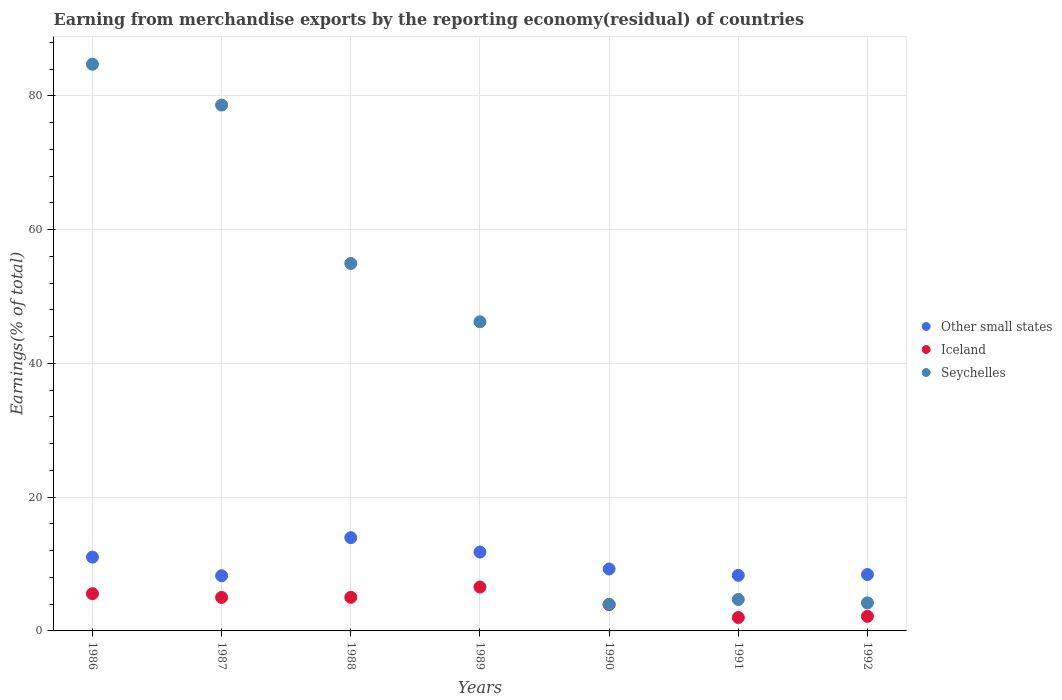How many different coloured dotlines are there?
Keep it short and to the point. 3. What is the percentage of amount earned from merchandise exports in Other small states in 1986?
Your response must be concise. 11.04. Across all years, what is the maximum percentage of amount earned from merchandise exports in Seychelles?
Ensure brevity in your answer.  84.75. Across all years, what is the minimum percentage of amount earned from merchandise exports in Iceland?
Offer a terse response. 2. In which year was the percentage of amount earned from merchandise exports in Other small states maximum?
Provide a short and direct response. 1988. In which year was the percentage of amount earned from merchandise exports in Seychelles minimum?
Make the answer very short. 1990. What is the total percentage of amount earned from merchandise exports in Seychelles in the graph?
Provide a succinct answer. 277.46. What is the difference between the percentage of amount earned from merchandise exports in Iceland in 1986 and that in 1988?
Keep it short and to the point. 0.54. What is the difference between the percentage of amount earned from merchandise exports in Other small states in 1991 and the percentage of amount earned from merchandise exports in Seychelles in 1990?
Ensure brevity in your answer.  4.33. What is the average percentage of amount earned from merchandise exports in Other small states per year?
Ensure brevity in your answer.  10.15. In the year 1987, what is the difference between the percentage of amount earned from merchandise exports in Other small states and percentage of amount earned from merchandise exports in Iceland?
Your response must be concise. 3.24. What is the ratio of the percentage of amount earned from merchandise exports in Seychelles in 1986 to that in 1992?
Provide a succinct answer. 20.19. Is the percentage of amount earned from merchandise exports in Other small states in 1988 less than that in 1992?
Provide a short and direct response. No. Is the difference between the percentage of amount earned from merchandise exports in Other small states in 1987 and 1992 greater than the difference between the percentage of amount earned from merchandise exports in Iceland in 1987 and 1992?
Keep it short and to the point. No. What is the difference between the highest and the second highest percentage of amount earned from merchandise exports in Iceland?
Provide a succinct answer. 1. What is the difference between the highest and the lowest percentage of amount earned from merchandise exports in Other small states?
Ensure brevity in your answer.  5.69. Is it the case that in every year, the sum of the percentage of amount earned from merchandise exports in Iceland and percentage of amount earned from merchandise exports in Seychelles  is greater than the percentage of amount earned from merchandise exports in Other small states?
Provide a succinct answer. No. Is the percentage of amount earned from merchandise exports in Iceland strictly less than the percentage of amount earned from merchandise exports in Seychelles over the years?
Offer a terse response. Yes. How many years are there in the graph?
Give a very brief answer. 7. Does the graph contain any zero values?
Keep it short and to the point. No. How many legend labels are there?
Ensure brevity in your answer.  3. How are the legend labels stacked?
Your answer should be compact. Vertical. What is the title of the graph?
Keep it short and to the point. Earning from merchandise exports by the reporting economy(residual) of countries. What is the label or title of the X-axis?
Provide a short and direct response. Years. What is the label or title of the Y-axis?
Your answer should be very brief. Earnings(% of total). What is the Earnings(% of total) in Other small states in 1986?
Ensure brevity in your answer.  11.04. What is the Earnings(% of total) of Iceland in 1986?
Keep it short and to the point. 5.56. What is the Earnings(% of total) in Seychelles in 1986?
Make the answer very short. 84.75. What is the Earnings(% of total) of Other small states in 1987?
Keep it short and to the point. 8.25. What is the Earnings(% of total) of Iceland in 1987?
Make the answer very short. 5.01. What is the Earnings(% of total) of Seychelles in 1987?
Offer a terse response. 78.64. What is the Earnings(% of total) of Other small states in 1988?
Give a very brief answer. 13.95. What is the Earnings(% of total) of Iceland in 1988?
Ensure brevity in your answer.  5.02. What is the Earnings(% of total) in Seychelles in 1988?
Keep it short and to the point. 54.95. What is the Earnings(% of total) in Other small states in 1989?
Your response must be concise. 11.79. What is the Earnings(% of total) of Iceland in 1989?
Provide a succinct answer. 6.56. What is the Earnings(% of total) in Seychelles in 1989?
Your answer should be very brief. 46.24. What is the Earnings(% of total) of Other small states in 1990?
Make the answer very short. 9.26. What is the Earnings(% of total) in Iceland in 1990?
Offer a very short reply. 3.94. What is the Earnings(% of total) of Seychelles in 1990?
Ensure brevity in your answer.  3.98. What is the Earnings(% of total) in Other small states in 1991?
Offer a very short reply. 8.31. What is the Earnings(% of total) of Iceland in 1991?
Offer a terse response. 2. What is the Earnings(% of total) of Seychelles in 1991?
Offer a very short reply. 4.7. What is the Earnings(% of total) of Other small states in 1992?
Your answer should be compact. 8.44. What is the Earnings(% of total) of Iceland in 1992?
Ensure brevity in your answer.  2.18. What is the Earnings(% of total) in Seychelles in 1992?
Keep it short and to the point. 4.2. Across all years, what is the maximum Earnings(% of total) in Other small states?
Your response must be concise. 13.95. Across all years, what is the maximum Earnings(% of total) of Iceland?
Make the answer very short. 6.56. Across all years, what is the maximum Earnings(% of total) in Seychelles?
Offer a terse response. 84.75. Across all years, what is the minimum Earnings(% of total) in Other small states?
Offer a terse response. 8.25. Across all years, what is the minimum Earnings(% of total) in Iceland?
Give a very brief answer. 2. Across all years, what is the minimum Earnings(% of total) of Seychelles?
Your answer should be very brief. 3.98. What is the total Earnings(% of total) of Other small states in the graph?
Offer a very short reply. 71.03. What is the total Earnings(% of total) in Iceland in the graph?
Your answer should be compact. 30.28. What is the total Earnings(% of total) in Seychelles in the graph?
Offer a terse response. 277.46. What is the difference between the Earnings(% of total) of Other small states in 1986 and that in 1987?
Give a very brief answer. 2.79. What is the difference between the Earnings(% of total) in Iceland in 1986 and that in 1987?
Provide a short and direct response. 0.55. What is the difference between the Earnings(% of total) in Seychelles in 1986 and that in 1987?
Offer a terse response. 6.11. What is the difference between the Earnings(% of total) in Other small states in 1986 and that in 1988?
Offer a very short reply. -2.91. What is the difference between the Earnings(% of total) of Iceland in 1986 and that in 1988?
Ensure brevity in your answer.  0.54. What is the difference between the Earnings(% of total) in Seychelles in 1986 and that in 1988?
Provide a short and direct response. 29.8. What is the difference between the Earnings(% of total) in Other small states in 1986 and that in 1989?
Provide a short and direct response. -0.75. What is the difference between the Earnings(% of total) of Iceland in 1986 and that in 1989?
Your answer should be compact. -1. What is the difference between the Earnings(% of total) of Seychelles in 1986 and that in 1989?
Ensure brevity in your answer.  38.51. What is the difference between the Earnings(% of total) in Other small states in 1986 and that in 1990?
Provide a short and direct response. 1.77. What is the difference between the Earnings(% of total) in Iceland in 1986 and that in 1990?
Give a very brief answer. 1.62. What is the difference between the Earnings(% of total) in Seychelles in 1986 and that in 1990?
Your response must be concise. 80.76. What is the difference between the Earnings(% of total) in Other small states in 1986 and that in 1991?
Offer a very short reply. 2.73. What is the difference between the Earnings(% of total) of Iceland in 1986 and that in 1991?
Offer a very short reply. 3.56. What is the difference between the Earnings(% of total) of Seychelles in 1986 and that in 1991?
Your answer should be compact. 80.04. What is the difference between the Earnings(% of total) in Other small states in 1986 and that in 1992?
Ensure brevity in your answer.  2.6. What is the difference between the Earnings(% of total) in Iceland in 1986 and that in 1992?
Your answer should be compact. 3.38. What is the difference between the Earnings(% of total) in Seychelles in 1986 and that in 1992?
Offer a very short reply. 80.55. What is the difference between the Earnings(% of total) in Other small states in 1987 and that in 1988?
Your answer should be compact. -5.69. What is the difference between the Earnings(% of total) in Iceland in 1987 and that in 1988?
Ensure brevity in your answer.  -0.01. What is the difference between the Earnings(% of total) in Seychelles in 1987 and that in 1988?
Keep it short and to the point. 23.69. What is the difference between the Earnings(% of total) in Other small states in 1987 and that in 1989?
Ensure brevity in your answer.  -3.54. What is the difference between the Earnings(% of total) of Iceland in 1987 and that in 1989?
Give a very brief answer. -1.55. What is the difference between the Earnings(% of total) of Seychelles in 1987 and that in 1989?
Your answer should be very brief. 32.4. What is the difference between the Earnings(% of total) in Other small states in 1987 and that in 1990?
Offer a very short reply. -1.01. What is the difference between the Earnings(% of total) of Iceland in 1987 and that in 1990?
Give a very brief answer. 1.08. What is the difference between the Earnings(% of total) of Seychelles in 1987 and that in 1990?
Your response must be concise. 74.66. What is the difference between the Earnings(% of total) in Other small states in 1987 and that in 1991?
Offer a terse response. -0.06. What is the difference between the Earnings(% of total) of Iceland in 1987 and that in 1991?
Make the answer very short. 3.01. What is the difference between the Earnings(% of total) of Seychelles in 1987 and that in 1991?
Offer a very short reply. 73.94. What is the difference between the Earnings(% of total) in Other small states in 1987 and that in 1992?
Ensure brevity in your answer.  -0.19. What is the difference between the Earnings(% of total) of Iceland in 1987 and that in 1992?
Provide a short and direct response. 2.83. What is the difference between the Earnings(% of total) in Seychelles in 1987 and that in 1992?
Provide a short and direct response. 74.44. What is the difference between the Earnings(% of total) of Other small states in 1988 and that in 1989?
Give a very brief answer. 2.16. What is the difference between the Earnings(% of total) in Iceland in 1988 and that in 1989?
Provide a succinct answer. -1.54. What is the difference between the Earnings(% of total) of Seychelles in 1988 and that in 1989?
Your answer should be very brief. 8.71. What is the difference between the Earnings(% of total) in Other small states in 1988 and that in 1990?
Make the answer very short. 4.68. What is the difference between the Earnings(% of total) of Iceland in 1988 and that in 1990?
Offer a terse response. 1.08. What is the difference between the Earnings(% of total) in Seychelles in 1988 and that in 1990?
Ensure brevity in your answer.  50.97. What is the difference between the Earnings(% of total) of Other small states in 1988 and that in 1991?
Provide a short and direct response. 5.64. What is the difference between the Earnings(% of total) in Iceland in 1988 and that in 1991?
Provide a succinct answer. 3.02. What is the difference between the Earnings(% of total) in Seychelles in 1988 and that in 1991?
Provide a succinct answer. 50.25. What is the difference between the Earnings(% of total) of Other small states in 1988 and that in 1992?
Ensure brevity in your answer.  5.51. What is the difference between the Earnings(% of total) of Iceland in 1988 and that in 1992?
Your response must be concise. 2.84. What is the difference between the Earnings(% of total) of Seychelles in 1988 and that in 1992?
Keep it short and to the point. 50.75. What is the difference between the Earnings(% of total) in Other small states in 1989 and that in 1990?
Provide a short and direct response. 2.53. What is the difference between the Earnings(% of total) of Iceland in 1989 and that in 1990?
Ensure brevity in your answer.  2.62. What is the difference between the Earnings(% of total) in Seychelles in 1989 and that in 1990?
Give a very brief answer. 42.25. What is the difference between the Earnings(% of total) in Other small states in 1989 and that in 1991?
Ensure brevity in your answer.  3.48. What is the difference between the Earnings(% of total) of Iceland in 1989 and that in 1991?
Keep it short and to the point. 4.56. What is the difference between the Earnings(% of total) of Seychelles in 1989 and that in 1991?
Make the answer very short. 41.54. What is the difference between the Earnings(% of total) in Other small states in 1989 and that in 1992?
Provide a succinct answer. 3.35. What is the difference between the Earnings(% of total) of Iceland in 1989 and that in 1992?
Give a very brief answer. 4.38. What is the difference between the Earnings(% of total) in Seychelles in 1989 and that in 1992?
Give a very brief answer. 42.04. What is the difference between the Earnings(% of total) in Other small states in 1990 and that in 1991?
Your answer should be compact. 0.95. What is the difference between the Earnings(% of total) in Iceland in 1990 and that in 1991?
Your answer should be very brief. 1.93. What is the difference between the Earnings(% of total) in Seychelles in 1990 and that in 1991?
Ensure brevity in your answer.  -0.72. What is the difference between the Earnings(% of total) of Other small states in 1990 and that in 1992?
Keep it short and to the point. 0.83. What is the difference between the Earnings(% of total) in Iceland in 1990 and that in 1992?
Offer a terse response. 1.76. What is the difference between the Earnings(% of total) in Seychelles in 1990 and that in 1992?
Give a very brief answer. -0.21. What is the difference between the Earnings(% of total) of Other small states in 1991 and that in 1992?
Provide a short and direct response. -0.13. What is the difference between the Earnings(% of total) of Iceland in 1991 and that in 1992?
Your response must be concise. -0.18. What is the difference between the Earnings(% of total) of Seychelles in 1991 and that in 1992?
Your answer should be very brief. 0.51. What is the difference between the Earnings(% of total) in Other small states in 1986 and the Earnings(% of total) in Iceland in 1987?
Offer a terse response. 6.02. What is the difference between the Earnings(% of total) in Other small states in 1986 and the Earnings(% of total) in Seychelles in 1987?
Keep it short and to the point. -67.6. What is the difference between the Earnings(% of total) in Iceland in 1986 and the Earnings(% of total) in Seychelles in 1987?
Make the answer very short. -73.08. What is the difference between the Earnings(% of total) of Other small states in 1986 and the Earnings(% of total) of Iceland in 1988?
Offer a terse response. 6.02. What is the difference between the Earnings(% of total) in Other small states in 1986 and the Earnings(% of total) in Seychelles in 1988?
Make the answer very short. -43.91. What is the difference between the Earnings(% of total) of Iceland in 1986 and the Earnings(% of total) of Seychelles in 1988?
Make the answer very short. -49.39. What is the difference between the Earnings(% of total) in Other small states in 1986 and the Earnings(% of total) in Iceland in 1989?
Provide a short and direct response. 4.48. What is the difference between the Earnings(% of total) in Other small states in 1986 and the Earnings(% of total) in Seychelles in 1989?
Keep it short and to the point. -35.2. What is the difference between the Earnings(% of total) in Iceland in 1986 and the Earnings(% of total) in Seychelles in 1989?
Provide a short and direct response. -40.68. What is the difference between the Earnings(% of total) of Other small states in 1986 and the Earnings(% of total) of Iceland in 1990?
Offer a terse response. 7.1. What is the difference between the Earnings(% of total) in Other small states in 1986 and the Earnings(% of total) in Seychelles in 1990?
Your answer should be compact. 7.05. What is the difference between the Earnings(% of total) in Iceland in 1986 and the Earnings(% of total) in Seychelles in 1990?
Make the answer very short. 1.58. What is the difference between the Earnings(% of total) in Other small states in 1986 and the Earnings(% of total) in Iceland in 1991?
Ensure brevity in your answer.  9.03. What is the difference between the Earnings(% of total) of Other small states in 1986 and the Earnings(% of total) of Seychelles in 1991?
Offer a terse response. 6.33. What is the difference between the Earnings(% of total) in Iceland in 1986 and the Earnings(% of total) in Seychelles in 1991?
Keep it short and to the point. 0.86. What is the difference between the Earnings(% of total) of Other small states in 1986 and the Earnings(% of total) of Iceland in 1992?
Offer a terse response. 8.86. What is the difference between the Earnings(% of total) of Other small states in 1986 and the Earnings(% of total) of Seychelles in 1992?
Offer a very short reply. 6.84. What is the difference between the Earnings(% of total) in Iceland in 1986 and the Earnings(% of total) in Seychelles in 1992?
Keep it short and to the point. 1.37. What is the difference between the Earnings(% of total) in Other small states in 1987 and the Earnings(% of total) in Iceland in 1988?
Make the answer very short. 3.23. What is the difference between the Earnings(% of total) of Other small states in 1987 and the Earnings(% of total) of Seychelles in 1988?
Your response must be concise. -46.7. What is the difference between the Earnings(% of total) in Iceland in 1987 and the Earnings(% of total) in Seychelles in 1988?
Give a very brief answer. -49.94. What is the difference between the Earnings(% of total) of Other small states in 1987 and the Earnings(% of total) of Iceland in 1989?
Offer a very short reply. 1.69. What is the difference between the Earnings(% of total) in Other small states in 1987 and the Earnings(% of total) in Seychelles in 1989?
Ensure brevity in your answer.  -37.99. What is the difference between the Earnings(% of total) of Iceland in 1987 and the Earnings(% of total) of Seychelles in 1989?
Keep it short and to the point. -41.22. What is the difference between the Earnings(% of total) of Other small states in 1987 and the Earnings(% of total) of Iceland in 1990?
Provide a short and direct response. 4.31. What is the difference between the Earnings(% of total) of Other small states in 1987 and the Earnings(% of total) of Seychelles in 1990?
Ensure brevity in your answer.  4.27. What is the difference between the Earnings(% of total) of Iceland in 1987 and the Earnings(% of total) of Seychelles in 1990?
Offer a terse response. 1.03. What is the difference between the Earnings(% of total) of Other small states in 1987 and the Earnings(% of total) of Iceland in 1991?
Your answer should be very brief. 6.25. What is the difference between the Earnings(% of total) of Other small states in 1987 and the Earnings(% of total) of Seychelles in 1991?
Your answer should be compact. 3.55. What is the difference between the Earnings(% of total) in Iceland in 1987 and the Earnings(% of total) in Seychelles in 1991?
Provide a succinct answer. 0.31. What is the difference between the Earnings(% of total) of Other small states in 1987 and the Earnings(% of total) of Iceland in 1992?
Your answer should be compact. 6.07. What is the difference between the Earnings(% of total) of Other small states in 1987 and the Earnings(% of total) of Seychelles in 1992?
Offer a terse response. 4.05. What is the difference between the Earnings(% of total) of Iceland in 1987 and the Earnings(% of total) of Seychelles in 1992?
Your answer should be very brief. 0.82. What is the difference between the Earnings(% of total) of Other small states in 1988 and the Earnings(% of total) of Iceland in 1989?
Ensure brevity in your answer.  7.39. What is the difference between the Earnings(% of total) of Other small states in 1988 and the Earnings(% of total) of Seychelles in 1989?
Ensure brevity in your answer.  -32.29. What is the difference between the Earnings(% of total) of Iceland in 1988 and the Earnings(% of total) of Seychelles in 1989?
Your answer should be compact. -41.22. What is the difference between the Earnings(% of total) of Other small states in 1988 and the Earnings(% of total) of Iceland in 1990?
Your answer should be compact. 10.01. What is the difference between the Earnings(% of total) of Other small states in 1988 and the Earnings(% of total) of Seychelles in 1990?
Offer a terse response. 9.96. What is the difference between the Earnings(% of total) in Iceland in 1988 and the Earnings(% of total) in Seychelles in 1990?
Give a very brief answer. 1.04. What is the difference between the Earnings(% of total) in Other small states in 1988 and the Earnings(% of total) in Iceland in 1991?
Ensure brevity in your answer.  11.94. What is the difference between the Earnings(% of total) in Other small states in 1988 and the Earnings(% of total) in Seychelles in 1991?
Your response must be concise. 9.24. What is the difference between the Earnings(% of total) of Iceland in 1988 and the Earnings(% of total) of Seychelles in 1991?
Your answer should be compact. 0.32. What is the difference between the Earnings(% of total) in Other small states in 1988 and the Earnings(% of total) in Iceland in 1992?
Keep it short and to the point. 11.77. What is the difference between the Earnings(% of total) of Other small states in 1988 and the Earnings(% of total) of Seychelles in 1992?
Provide a short and direct response. 9.75. What is the difference between the Earnings(% of total) in Iceland in 1988 and the Earnings(% of total) in Seychelles in 1992?
Your answer should be very brief. 0.82. What is the difference between the Earnings(% of total) in Other small states in 1989 and the Earnings(% of total) in Iceland in 1990?
Your response must be concise. 7.85. What is the difference between the Earnings(% of total) of Other small states in 1989 and the Earnings(% of total) of Seychelles in 1990?
Provide a short and direct response. 7.81. What is the difference between the Earnings(% of total) in Iceland in 1989 and the Earnings(% of total) in Seychelles in 1990?
Your response must be concise. 2.58. What is the difference between the Earnings(% of total) of Other small states in 1989 and the Earnings(% of total) of Iceland in 1991?
Offer a very short reply. 9.79. What is the difference between the Earnings(% of total) in Other small states in 1989 and the Earnings(% of total) in Seychelles in 1991?
Your answer should be compact. 7.09. What is the difference between the Earnings(% of total) of Iceland in 1989 and the Earnings(% of total) of Seychelles in 1991?
Offer a very short reply. 1.86. What is the difference between the Earnings(% of total) of Other small states in 1989 and the Earnings(% of total) of Iceland in 1992?
Make the answer very short. 9.61. What is the difference between the Earnings(% of total) of Other small states in 1989 and the Earnings(% of total) of Seychelles in 1992?
Your answer should be compact. 7.59. What is the difference between the Earnings(% of total) of Iceland in 1989 and the Earnings(% of total) of Seychelles in 1992?
Your answer should be compact. 2.36. What is the difference between the Earnings(% of total) in Other small states in 1990 and the Earnings(% of total) in Iceland in 1991?
Keep it short and to the point. 7.26. What is the difference between the Earnings(% of total) in Other small states in 1990 and the Earnings(% of total) in Seychelles in 1991?
Your response must be concise. 4.56. What is the difference between the Earnings(% of total) of Iceland in 1990 and the Earnings(% of total) of Seychelles in 1991?
Make the answer very short. -0.76. What is the difference between the Earnings(% of total) in Other small states in 1990 and the Earnings(% of total) in Iceland in 1992?
Your answer should be compact. 7.08. What is the difference between the Earnings(% of total) in Other small states in 1990 and the Earnings(% of total) in Seychelles in 1992?
Provide a succinct answer. 5.07. What is the difference between the Earnings(% of total) in Iceland in 1990 and the Earnings(% of total) in Seychelles in 1992?
Your response must be concise. -0.26. What is the difference between the Earnings(% of total) of Other small states in 1991 and the Earnings(% of total) of Iceland in 1992?
Offer a very short reply. 6.13. What is the difference between the Earnings(% of total) of Other small states in 1991 and the Earnings(% of total) of Seychelles in 1992?
Keep it short and to the point. 4.11. What is the difference between the Earnings(% of total) in Iceland in 1991 and the Earnings(% of total) in Seychelles in 1992?
Make the answer very short. -2.19. What is the average Earnings(% of total) of Other small states per year?
Ensure brevity in your answer.  10.15. What is the average Earnings(% of total) in Iceland per year?
Your answer should be very brief. 4.33. What is the average Earnings(% of total) of Seychelles per year?
Offer a terse response. 39.64. In the year 1986, what is the difference between the Earnings(% of total) in Other small states and Earnings(% of total) in Iceland?
Keep it short and to the point. 5.47. In the year 1986, what is the difference between the Earnings(% of total) in Other small states and Earnings(% of total) in Seychelles?
Make the answer very short. -73.71. In the year 1986, what is the difference between the Earnings(% of total) of Iceland and Earnings(% of total) of Seychelles?
Give a very brief answer. -79.18. In the year 1987, what is the difference between the Earnings(% of total) of Other small states and Earnings(% of total) of Iceland?
Give a very brief answer. 3.24. In the year 1987, what is the difference between the Earnings(% of total) of Other small states and Earnings(% of total) of Seychelles?
Your response must be concise. -70.39. In the year 1987, what is the difference between the Earnings(% of total) of Iceland and Earnings(% of total) of Seychelles?
Your answer should be compact. -73.63. In the year 1988, what is the difference between the Earnings(% of total) in Other small states and Earnings(% of total) in Iceland?
Your response must be concise. 8.92. In the year 1988, what is the difference between the Earnings(% of total) in Other small states and Earnings(% of total) in Seychelles?
Give a very brief answer. -41. In the year 1988, what is the difference between the Earnings(% of total) of Iceland and Earnings(% of total) of Seychelles?
Keep it short and to the point. -49.93. In the year 1989, what is the difference between the Earnings(% of total) of Other small states and Earnings(% of total) of Iceland?
Make the answer very short. 5.23. In the year 1989, what is the difference between the Earnings(% of total) of Other small states and Earnings(% of total) of Seychelles?
Ensure brevity in your answer.  -34.45. In the year 1989, what is the difference between the Earnings(% of total) of Iceland and Earnings(% of total) of Seychelles?
Give a very brief answer. -39.68. In the year 1990, what is the difference between the Earnings(% of total) of Other small states and Earnings(% of total) of Iceland?
Keep it short and to the point. 5.33. In the year 1990, what is the difference between the Earnings(% of total) of Other small states and Earnings(% of total) of Seychelles?
Offer a terse response. 5.28. In the year 1990, what is the difference between the Earnings(% of total) of Iceland and Earnings(% of total) of Seychelles?
Give a very brief answer. -0.05. In the year 1991, what is the difference between the Earnings(% of total) of Other small states and Earnings(% of total) of Iceland?
Ensure brevity in your answer.  6.31. In the year 1991, what is the difference between the Earnings(% of total) in Other small states and Earnings(% of total) in Seychelles?
Ensure brevity in your answer.  3.61. In the year 1991, what is the difference between the Earnings(% of total) in Iceland and Earnings(% of total) in Seychelles?
Provide a succinct answer. -2.7. In the year 1992, what is the difference between the Earnings(% of total) in Other small states and Earnings(% of total) in Iceland?
Keep it short and to the point. 6.26. In the year 1992, what is the difference between the Earnings(% of total) in Other small states and Earnings(% of total) in Seychelles?
Make the answer very short. 4.24. In the year 1992, what is the difference between the Earnings(% of total) of Iceland and Earnings(% of total) of Seychelles?
Your answer should be compact. -2.02. What is the ratio of the Earnings(% of total) of Other small states in 1986 to that in 1987?
Ensure brevity in your answer.  1.34. What is the ratio of the Earnings(% of total) in Iceland in 1986 to that in 1987?
Your answer should be compact. 1.11. What is the ratio of the Earnings(% of total) of Seychelles in 1986 to that in 1987?
Provide a short and direct response. 1.08. What is the ratio of the Earnings(% of total) of Other small states in 1986 to that in 1988?
Offer a terse response. 0.79. What is the ratio of the Earnings(% of total) of Iceland in 1986 to that in 1988?
Offer a terse response. 1.11. What is the ratio of the Earnings(% of total) of Seychelles in 1986 to that in 1988?
Provide a succinct answer. 1.54. What is the ratio of the Earnings(% of total) of Other small states in 1986 to that in 1989?
Your answer should be very brief. 0.94. What is the ratio of the Earnings(% of total) in Iceland in 1986 to that in 1989?
Make the answer very short. 0.85. What is the ratio of the Earnings(% of total) of Seychelles in 1986 to that in 1989?
Your answer should be very brief. 1.83. What is the ratio of the Earnings(% of total) of Other small states in 1986 to that in 1990?
Offer a terse response. 1.19. What is the ratio of the Earnings(% of total) in Iceland in 1986 to that in 1990?
Your answer should be compact. 1.41. What is the ratio of the Earnings(% of total) in Seychelles in 1986 to that in 1990?
Make the answer very short. 21.27. What is the ratio of the Earnings(% of total) of Other small states in 1986 to that in 1991?
Provide a short and direct response. 1.33. What is the ratio of the Earnings(% of total) in Iceland in 1986 to that in 1991?
Your answer should be compact. 2.78. What is the ratio of the Earnings(% of total) in Seychelles in 1986 to that in 1991?
Keep it short and to the point. 18.02. What is the ratio of the Earnings(% of total) of Other small states in 1986 to that in 1992?
Offer a very short reply. 1.31. What is the ratio of the Earnings(% of total) in Iceland in 1986 to that in 1992?
Provide a succinct answer. 2.55. What is the ratio of the Earnings(% of total) of Seychelles in 1986 to that in 1992?
Offer a terse response. 20.19. What is the ratio of the Earnings(% of total) of Other small states in 1987 to that in 1988?
Make the answer very short. 0.59. What is the ratio of the Earnings(% of total) of Iceland in 1987 to that in 1988?
Offer a very short reply. 1. What is the ratio of the Earnings(% of total) in Seychelles in 1987 to that in 1988?
Provide a succinct answer. 1.43. What is the ratio of the Earnings(% of total) of Other small states in 1987 to that in 1989?
Provide a short and direct response. 0.7. What is the ratio of the Earnings(% of total) in Iceland in 1987 to that in 1989?
Ensure brevity in your answer.  0.76. What is the ratio of the Earnings(% of total) in Seychelles in 1987 to that in 1989?
Provide a succinct answer. 1.7. What is the ratio of the Earnings(% of total) of Other small states in 1987 to that in 1990?
Your response must be concise. 0.89. What is the ratio of the Earnings(% of total) in Iceland in 1987 to that in 1990?
Offer a very short reply. 1.27. What is the ratio of the Earnings(% of total) of Seychelles in 1987 to that in 1990?
Offer a very short reply. 19.74. What is the ratio of the Earnings(% of total) of Other small states in 1987 to that in 1991?
Make the answer very short. 0.99. What is the ratio of the Earnings(% of total) of Iceland in 1987 to that in 1991?
Your answer should be very brief. 2.5. What is the ratio of the Earnings(% of total) in Seychelles in 1987 to that in 1991?
Offer a terse response. 16.73. What is the ratio of the Earnings(% of total) in Other small states in 1987 to that in 1992?
Your response must be concise. 0.98. What is the ratio of the Earnings(% of total) in Iceland in 1987 to that in 1992?
Provide a short and direct response. 2.3. What is the ratio of the Earnings(% of total) in Seychelles in 1987 to that in 1992?
Offer a terse response. 18.74. What is the ratio of the Earnings(% of total) in Other small states in 1988 to that in 1989?
Provide a short and direct response. 1.18. What is the ratio of the Earnings(% of total) of Iceland in 1988 to that in 1989?
Offer a terse response. 0.77. What is the ratio of the Earnings(% of total) of Seychelles in 1988 to that in 1989?
Provide a short and direct response. 1.19. What is the ratio of the Earnings(% of total) in Other small states in 1988 to that in 1990?
Ensure brevity in your answer.  1.51. What is the ratio of the Earnings(% of total) of Iceland in 1988 to that in 1990?
Provide a short and direct response. 1.27. What is the ratio of the Earnings(% of total) in Seychelles in 1988 to that in 1990?
Offer a very short reply. 13.79. What is the ratio of the Earnings(% of total) of Other small states in 1988 to that in 1991?
Make the answer very short. 1.68. What is the ratio of the Earnings(% of total) of Iceland in 1988 to that in 1991?
Give a very brief answer. 2.51. What is the ratio of the Earnings(% of total) in Seychelles in 1988 to that in 1991?
Your answer should be compact. 11.69. What is the ratio of the Earnings(% of total) of Other small states in 1988 to that in 1992?
Keep it short and to the point. 1.65. What is the ratio of the Earnings(% of total) of Iceland in 1988 to that in 1992?
Offer a terse response. 2.3. What is the ratio of the Earnings(% of total) in Seychelles in 1988 to that in 1992?
Give a very brief answer. 13.09. What is the ratio of the Earnings(% of total) in Other small states in 1989 to that in 1990?
Offer a terse response. 1.27. What is the ratio of the Earnings(% of total) in Iceland in 1989 to that in 1990?
Make the answer very short. 1.67. What is the ratio of the Earnings(% of total) in Seychelles in 1989 to that in 1990?
Offer a very short reply. 11.61. What is the ratio of the Earnings(% of total) of Other small states in 1989 to that in 1991?
Offer a very short reply. 1.42. What is the ratio of the Earnings(% of total) in Iceland in 1989 to that in 1991?
Give a very brief answer. 3.27. What is the ratio of the Earnings(% of total) in Seychelles in 1989 to that in 1991?
Your answer should be compact. 9.83. What is the ratio of the Earnings(% of total) in Other small states in 1989 to that in 1992?
Offer a very short reply. 1.4. What is the ratio of the Earnings(% of total) of Iceland in 1989 to that in 1992?
Give a very brief answer. 3.01. What is the ratio of the Earnings(% of total) of Seychelles in 1989 to that in 1992?
Your answer should be compact. 11.02. What is the ratio of the Earnings(% of total) of Other small states in 1990 to that in 1991?
Provide a short and direct response. 1.11. What is the ratio of the Earnings(% of total) of Iceland in 1990 to that in 1991?
Your response must be concise. 1.97. What is the ratio of the Earnings(% of total) of Seychelles in 1990 to that in 1991?
Make the answer very short. 0.85. What is the ratio of the Earnings(% of total) in Other small states in 1990 to that in 1992?
Offer a terse response. 1.1. What is the ratio of the Earnings(% of total) in Iceland in 1990 to that in 1992?
Offer a very short reply. 1.81. What is the ratio of the Earnings(% of total) of Seychelles in 1990 to that in 1992?
Make the answer very short. 0.95. What is the ratio of the Earnings(% of total) in Other small states in 1991 to that in 1992?
Your answer should be compact. 0.98. What is the ratio of the Earnings(% of total) in Iceland in 1991 to that in 1992?
Provide a succinct answer. 0.92. What is the ratio of the Earnings(% of total) in Seychelles in 1991 to that in 1992?
Provide a short and direct response. 1.12. What is the difference between the highest and the second highest Earnings(% of total) in Other small states?
Your answer should be very brief. 2.16. What is the difference between the highest and the second highest Earnings(% of total) in Iceland?
Provide a succinct answer. 1. What is the difference between the highest and the second highest Earnings(% of total) of Seychelles?
Your answer should be very brief. 6.11. What is the difference between the highest and the lowest Earnings(% of total) of Other small states?
Ensure brevity in your answer.  5.69. What is the difference between the highest and the lowest Earnings(% of total) in Iceland?
Your response must be concise. 4.56. What is the difference between the highest and the lowest Earnings(% of total) of Seychelles?
Your answer should be very brief. 80.76. 